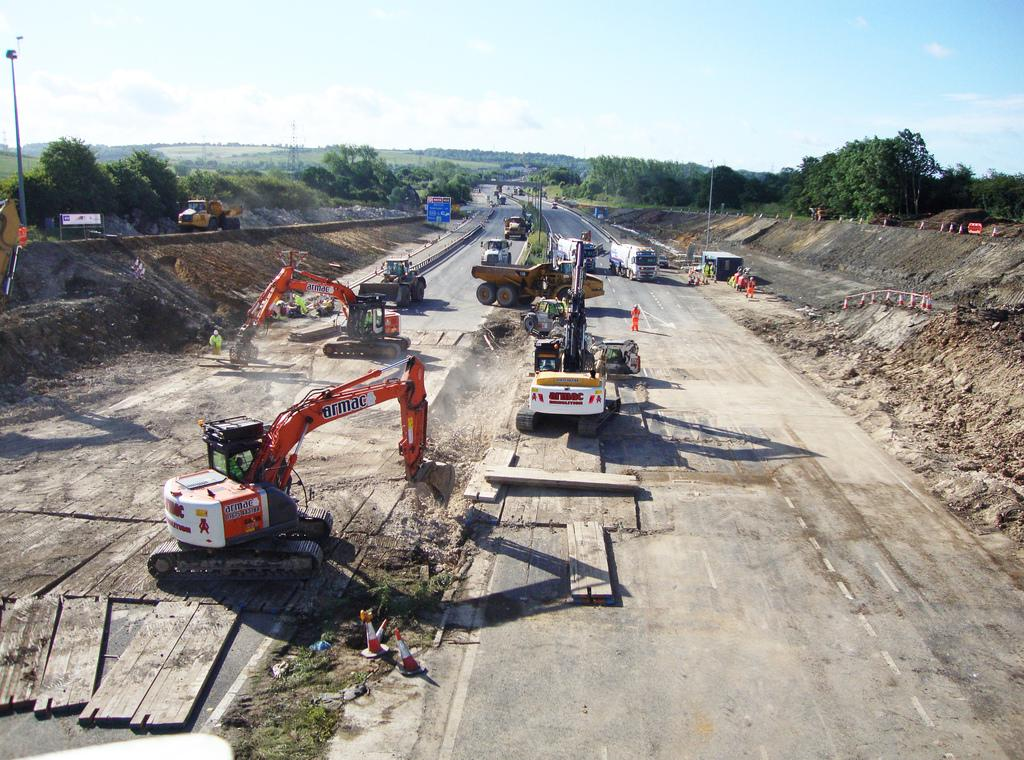<image>
Give a short and clear explanation of the subsequent image. A highway is under construction and bulldozers that say armac are digging the dirt up. 